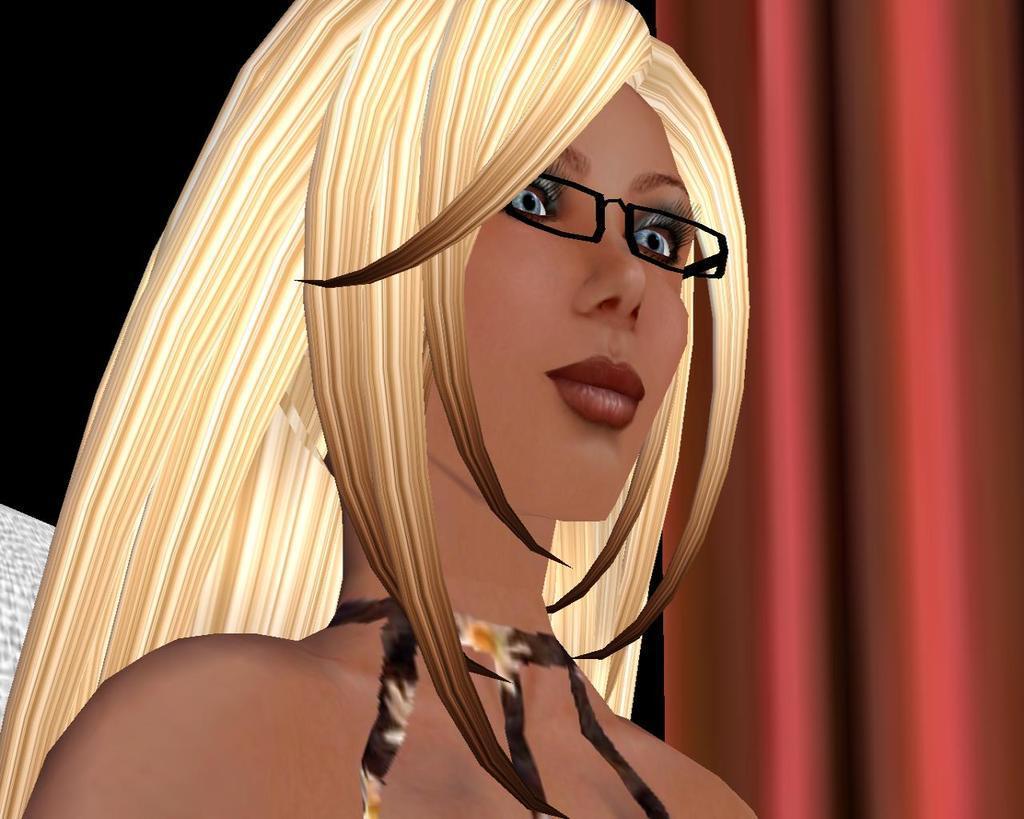How would you summarize this image in a sentence or two? This is an animated image, there is a person truncated towards the top of the image, there is wearing spectacles, there is an object truncated towards the left of the image, there is an object truncated towards the right of the image, the background of the image is dark. 